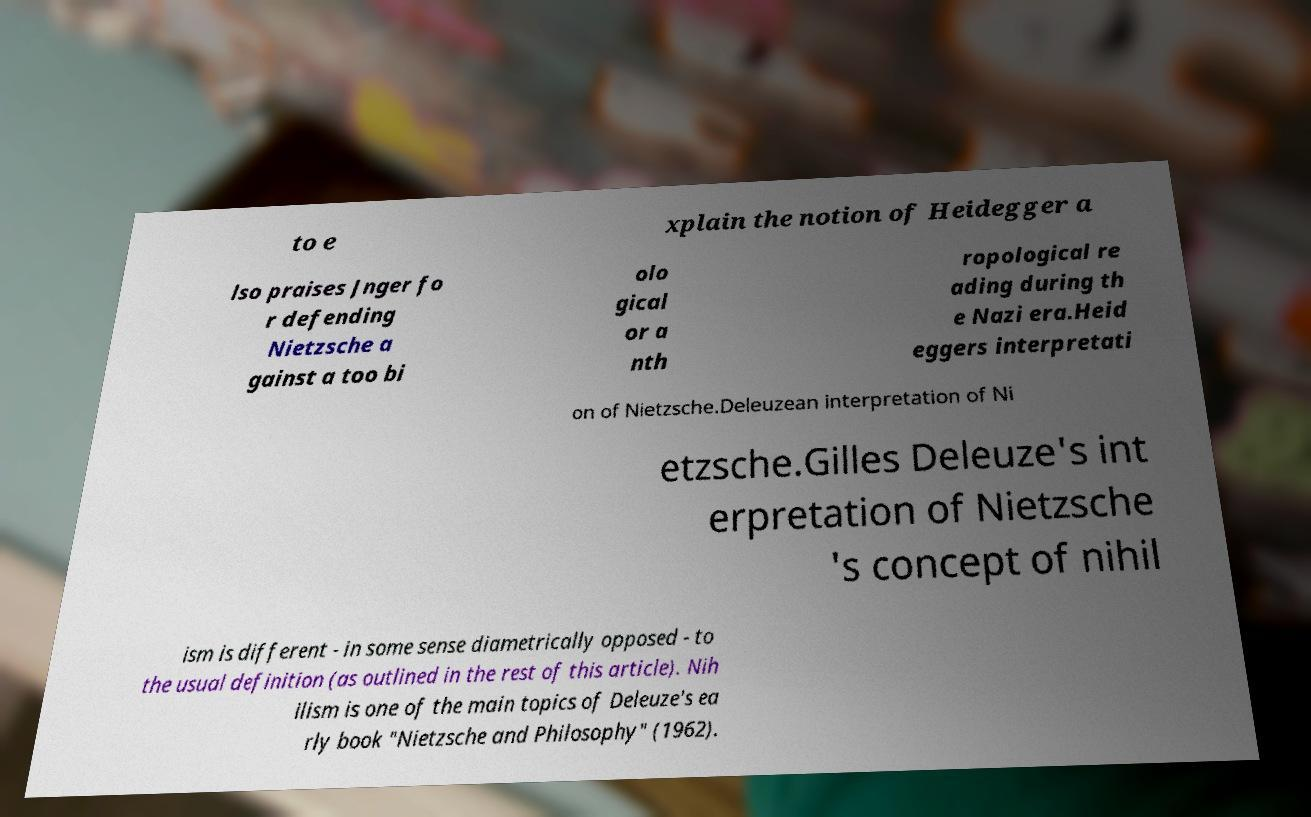Can you read and provide the text displayed in the image?This photo seems to have some interesting text. Can you extract and type it out for me? to e xplain the notion of Heidegger a lso praises Jnger fo r defending Nietzsche a gainst a too bi olo gical or a nth ropological re ading during th e Nazi era.Heid eggers interpretati on of Nietzsche.Deleuzean interpretation of Ni etzsche.Gilles Deleuze's int erpretation of Nietzsche 's concept of nihil ism is different - in some sense diametrically opposed - to the usual definition (as outlined in the rest of this article). Nih ilism is one of the main topics of Deleuze's ea rly book "Nietzsche and Philosophy" (1962). 